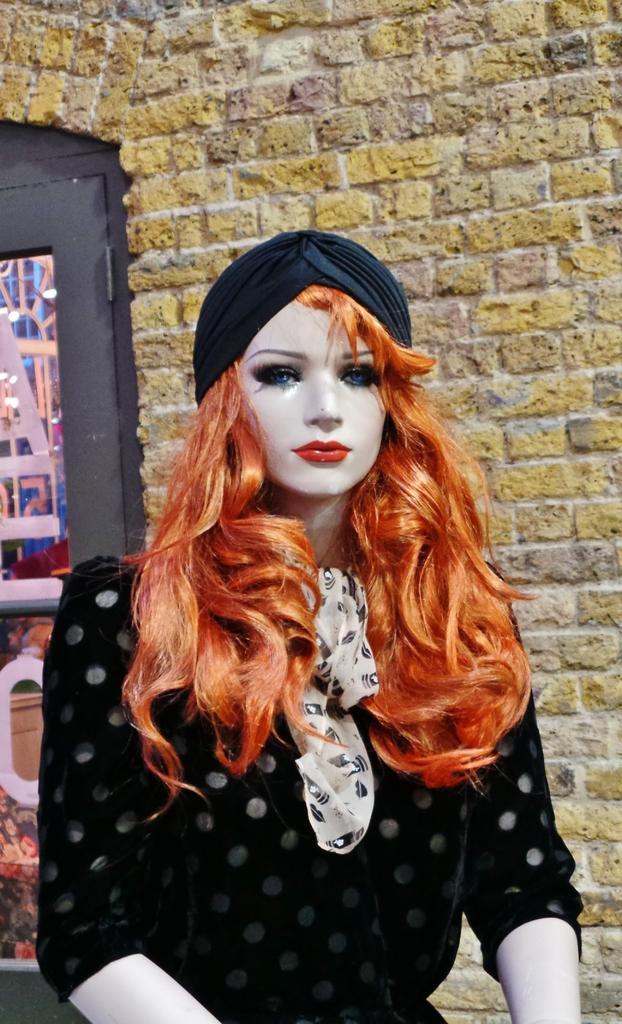In one or two sentences, can you explain what this image depicts? In this image, in the middle, we can see a doll wearing a black color dress. On the left side, we can also see a glass window. In the background, we can see a brick wall. 